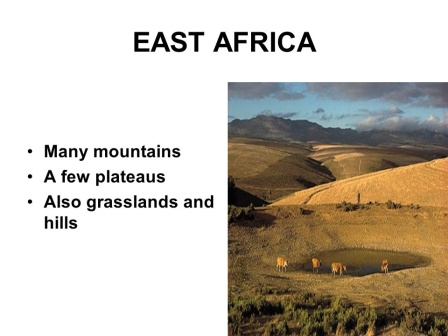What might a typical day look like for a photographer capturing this scene? A typical day for a photographer in East Africa capturing this scenic beauty would likely begin in the early morning before dawn. As the first light breaks, they set up their equipment to capture the golden hour, where the soft light highlights the contours of the landscape and the wildlife begins to stir. Patience is key as they wait for the perfect moment when the elephants emerge from the trees, following their ancient paths. The day would involve moving between different vantage points, perhaps using a 4x4 vehicle, to capture various perspectives of the valley, the mountains, and the diverse wildlife. The photographer would need to be alert, as opportunities arise unpredictably in the wild. As the sun sets, casting a fiery glow over the landscape, they would take advantage of the changing colors to capture breathtaking shots. The day ends with reviewing and sorting through hundreds of photos, selecting the ones that best convey the stunning beauty and diversity of East Africa. 